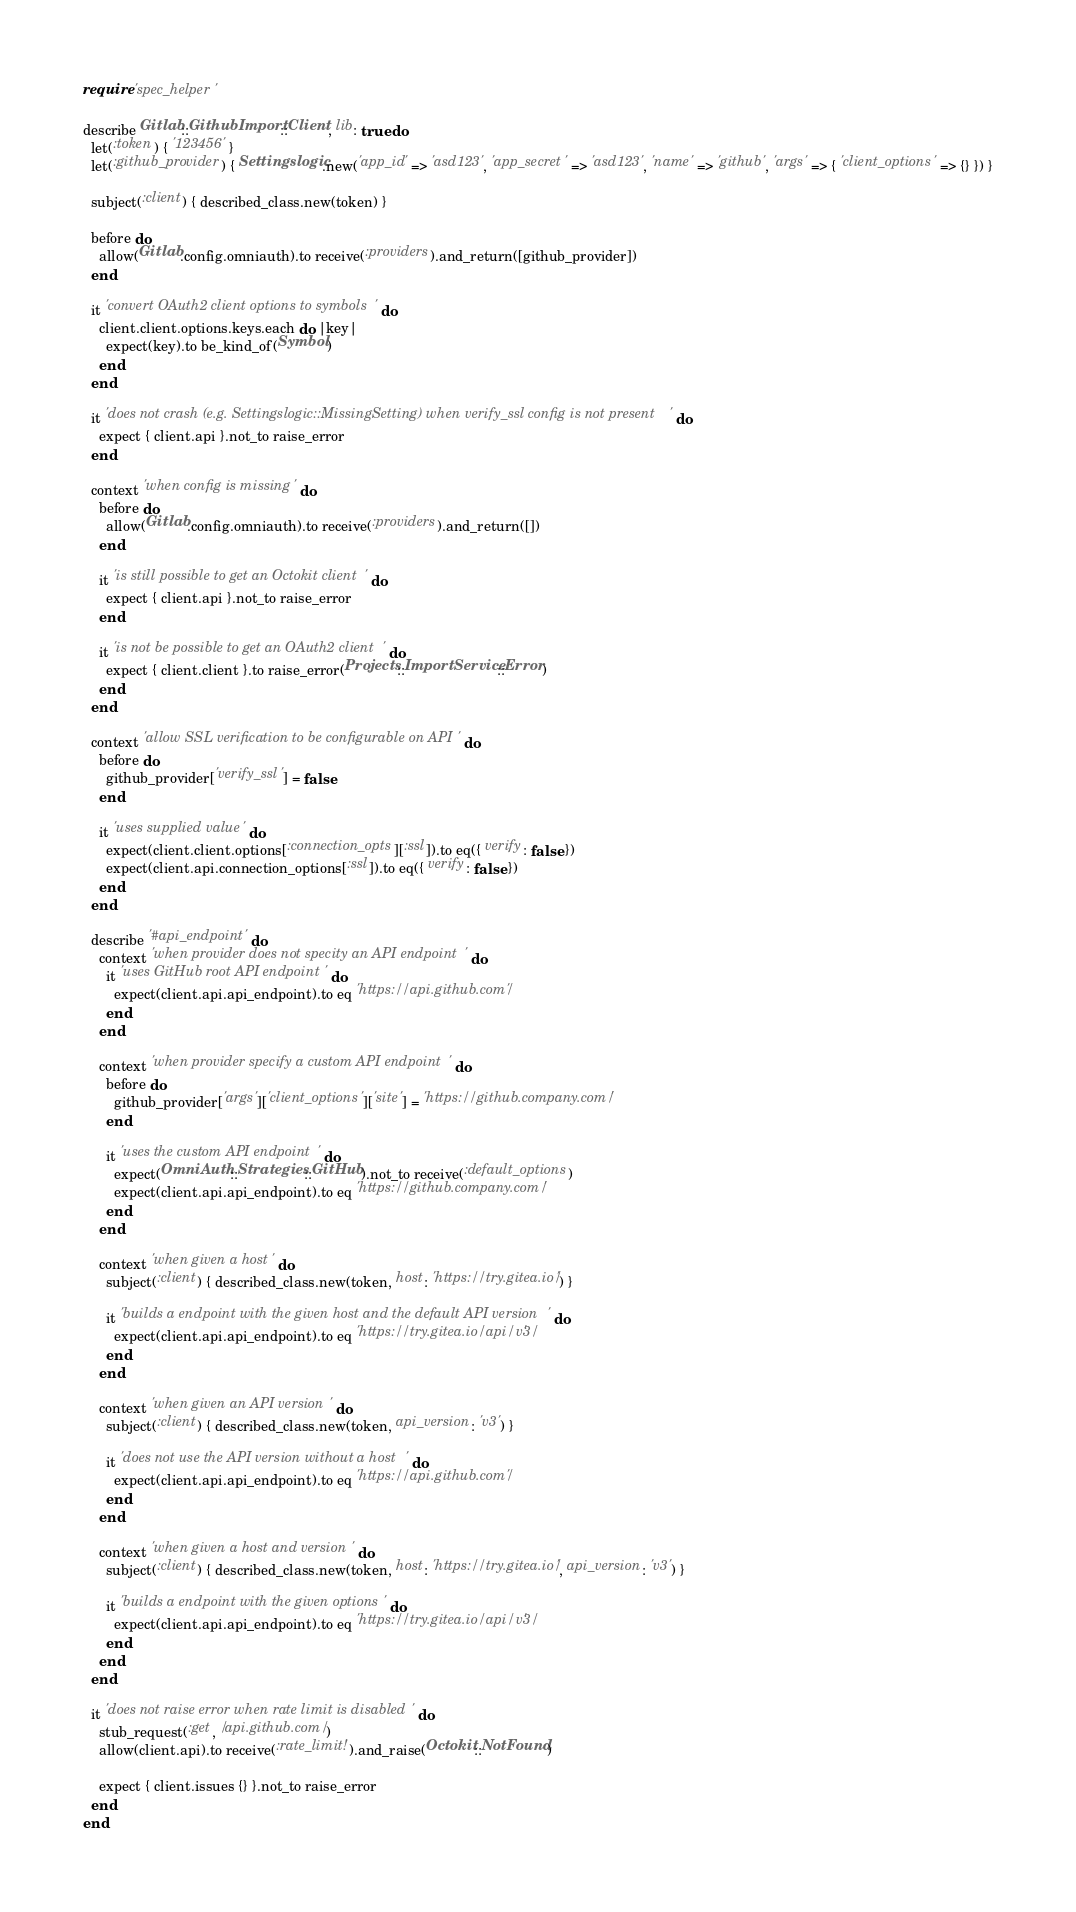Convert code to text. <code><loc_0><loc_0><loc_500><loc_500><_Ruby_>require 'spec_helper'

describe Gitlab::GithubImport::Client, lib: true do
  let(:token) { '123456' }
  let(:github_provider) { Settingslogic.new('app_id' => 'asd123', 'app_secret' => 'asd123', 'name' => 'github', 'args' => { 'client_options' => {} }) }

  subject(:client) { described_class.new(token) }

  before do
    allow(Gitlab.config.omniauth).to receive(:providers).and_return([github_provider])
  end

  it 'convert OAuth2 client options to symbols' do
    client.client.options.keys.each do |key|
      expect(key).to be_kind_of(Symbol)
    end
  end

  it 'does not crash (e.g. Settingslogic::MissingSetting) when verify_ssl config is not present' do
    expect { client.api }.not_to raise_error
  end

  context 'when config is missing' do
    before do
      allow(Gitlab.config.omniauth).to receive(:providers).and_return([])
    end

    it 'is still possible to get an Octokit client' do
      expect { client.api }.not_to raise_error
    end

    it 'is not be possible to get an OAuth2 client' do
      expect { client.client }.to raise_error(Projects::ImportService::Error)
    end
  end

  context 'allow SSL verification to be configurable on API' do
    before do
      github_provider['verify_ssl'] = false
    end

    it 'uses supplied value' do
      expect(client.client.options[:connection_opts][:ssl]).to eq({ verify: false })
      expect(client.api.connection_options[:ssl]).to eq({ verify: false })
    end
  end

  describe '#api_endpoint' do
    context 'when provider does not specity an API endpoint' do
      it 'uses GitHub root API endpoint' do
        expect(client.api.api_endpoint).to eq 'https://api.github.com/'
      end
    end

    context 'when provider specify a custom API endpoint' do
      before do
        github_provider['args']['client_options']['site'] = 'https://github.company.com/'
      end

      it 'uses the custom API endpoint' do
        expect(OmniAuth::Strategies::GitHub).not_to receive(:default_options)
        expect(client.api.api_endpoint).to eq 'https://github.company.com/'
      end
    end

    context 'when given a host' do
      subject(:client) { described_class.new(token, host: 'https://try.gitea.io/') }

      it 'builds a endpoint with the given host and the default API version' do
        expect(client.api.api_endpoint).to eq 'https://try.gitea.io/api/v3/'
      end
    end

    context 'when given an API version' do
      subject(:client) { described_class.new(token, api_version: 'v3') }

      it 'does not use the API version without a host' do
        expect(client.api.api_endpoint).to eq 'https://api.github.com/'
      end
    end

    context 'when given a host and version' do
      subject(:client) { described_class.new(token, host: 'https://try.gitea.io/', api_version: 'v3') }

      it 'builds a endpoint with the given options' do
        expect(client.api.api_endpoint).to eq 'https://try.gitea.io/api/v3/'
      end
    end
  end

  it 'does not raise error when rate limit is disabled' do
    stub_request(:get, /api.github.com/)
    allow(client.api).to receive(:rate_limit!).and_raise(Octokit::NotFound)

    expect { client.issues {} }.not_to raise_error
  end
end
</code> 